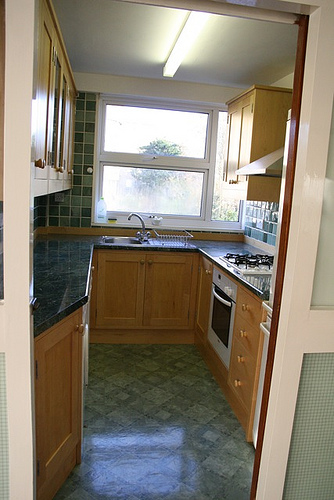What do you think the owner of this kitchen likes to cook? Given the cozy and well-organized setup of this kitchen, the owner might enjoy cooking wholesome, home-cooked meals. Perhaps they delight in preparing hearty stews, baking fresh bread, or even indulging in a bit of baking, given the functional counter space and modern appliances. 